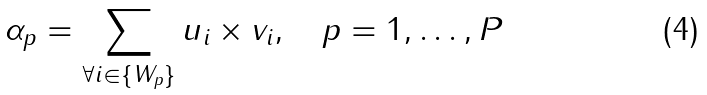<formula> <loc_0><loc_0><loc_500><loc_500>\alpha _ { p } = \sum _ { \forall i \in \{ W _ { p } \} } { u _ { i } \times v _ { i } } , \quad p = 1 , \dots , P</formula> 